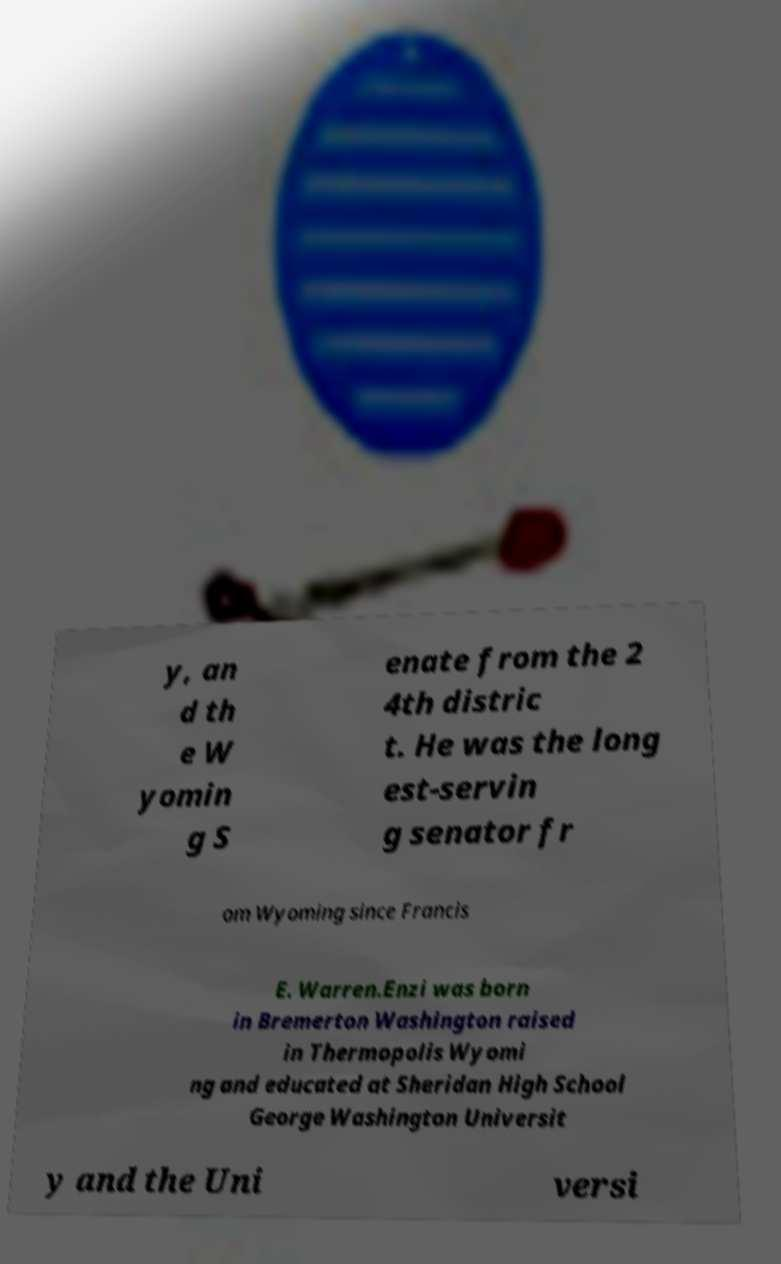Can you accurately transcribe the text from the provided image for me? y, an d th e W yomin g S enate from the 2 4th distric t. He was the long est-servin g senator fr om Wyoming since Francis E. Warren.Enzi was born in Bremerton Washington raised in Thermopolis Wyomi ng and educated at Sheridan High School George Washington Universit y and the Uni versi 